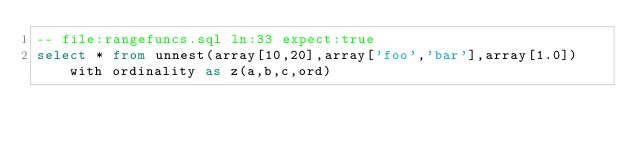Convert code to text. <code><loc_0><loc_0><loc_500><loc_500><_SQL_>-- file:rangefuncs.sql ln:33 expect:true
select * from unnest(array[10,20],array['foo','bar'],array[1.0]) with ordinality as z(a,b,c,ord)
</code> 